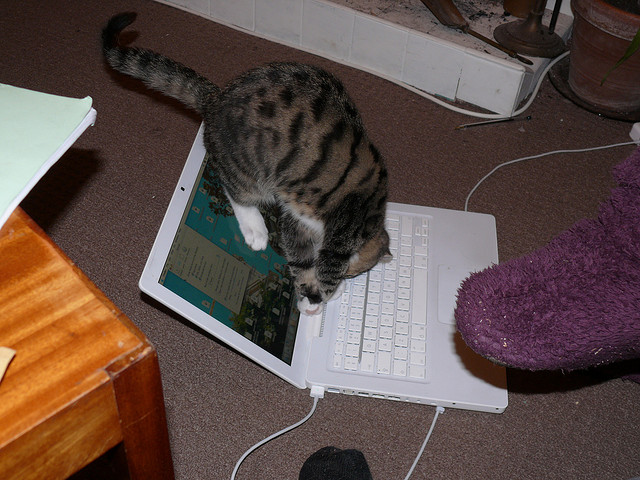<image>Does the owner of this cat enjoy Manga? I don't know if the owner of the cat enjoys Manga. Does the owner of this cat enjoy Manga? I don't know if the owner of this cat enjoys Manga. 